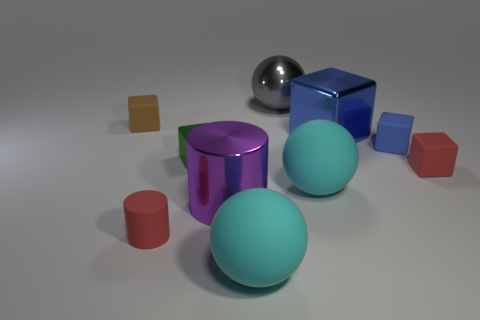Is the tiny green shiny thing the same shape as the tiny blue matte thing?
Your response must be concise. Yes. There is a thing that is right of the brown block and to the left of the small green metal thing; what size is it?
Offer a terse response. Small. What material is the large blue object that is the same shape as the small brown thing?
Offer a terse response. Metal. What material is the red thing on the left side of the large metallic thing behind the brown matte block?
Keep it short and to the point. Rubber. Do the tiny green object and the small red thing on the right side of the tiny green shiny block have the same shape?
Your answer should be compact. Yes. How many rubber things are either small blue cubes or large yellow things?
Make the answer very short. 1. There is a small cube that is on the left side of the red matte object in front of the red rubber thing right of the tiny metal cube; what color is it?
Ensure brevity in your answer.  Brown. How many other objects are the same material as the tiny red cylinder?
Give a very brief answer. 5. Does the small red thing that is in front of the small red rubber cube have the same shape as the purple shiny object?
Provide a short and direct response. Yes. What number of large things are either gray things or cyan spheres?
Provide a short and direct response. 3. 